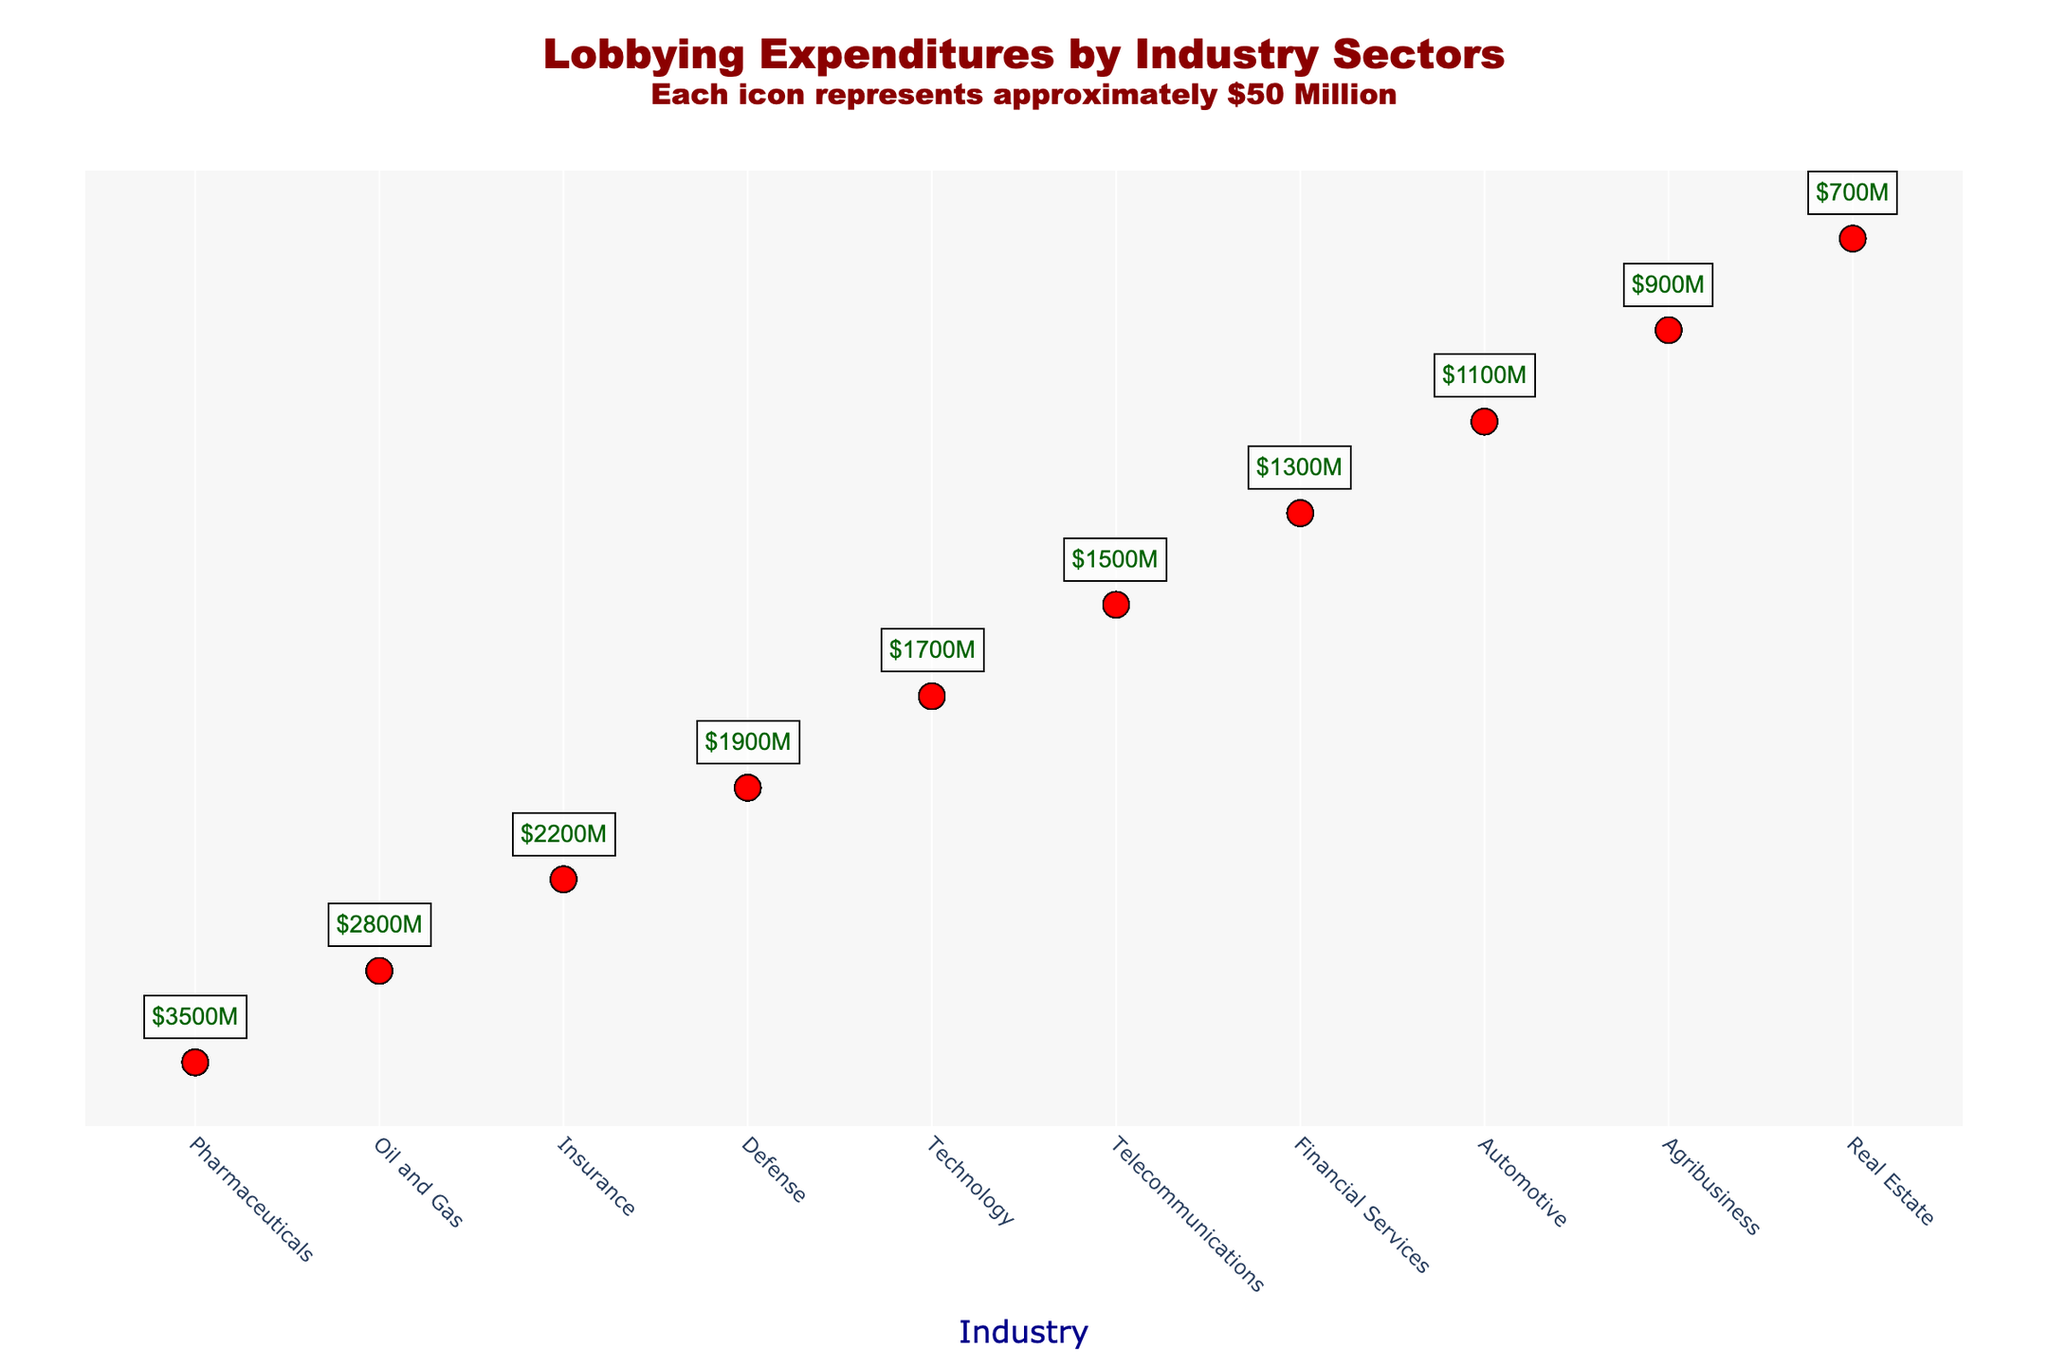What's the highest lobbying expenditure by an industry sector? By examining the plot, the Pharmaceutical industry shows the highest number of icons, which translate to the highest expenditure. Checking the exact amount, each icon represents $50 million, and Pharmaceuticals have 70 icons. 70 icons multiplied by $50 million equals $3500 million.
Answer: $3500 million Which two industries have the closest lobbying expenditures? By counting the icons for each industry, you can observe that the Technology sector, which has 34 icons, and Telecommunications sector, which has 30 icons, have the closest number of icons. Hence, their expenditures would be relatively close, with Technology at $1700 million and Telecommunications at $1500 million. The difference is $200 million.
Answer: Technology and Telecommunications What is the total lobbying expenditure of the top three industries? Identify the top three industries by their icon counts: Pharmaceuticals (70 icons), Oil and Gas (56 icons), and Insurance (44 icons). Calculating the total expenditure: (70 * $50 million) + (56 * $50 million) + (44 * $50 million) = $3500 million + $2800 million + $2200 million = $8500 million.
Answer: $8500 million Which industry has spent the least on lobbying? The plot shows the Real Estate industry at the bottom with only 14 icons. Therefore, Real Estate spent 14 * $50 million = $700 million.
Answer: Real Estate How much more did the Defense sector spend compared to Agribusiness? The Defense sector has 38 icons while Agribusiness has 18 icons. Calculating their expenditures: Defense spent 38 * $50 million = $1900 million; Agribusiness spent 18 * $50 million = $900 million. The difference is $1900 million - $900 million = $1000 million.
Answer: $1000 million What's the average expenditure across all industry sectors shown in the plot? Sum all industry expenditures: (70+56+44+38+34+30+26+22+18+14) * $50 million = 3520 total icons * $50 million = $17600 million total expenditure. Divide by the number of industries (10): $17600 million / 10 = $1760 million.
Answer: $1760 million Which sectors have more than $2000 million in lobbying expenditures? Count the icons and convert to expenditure: Pharmaceuticals (70 icons, $3500 million), Oil and Gas (56 icons, $2800 million), and Insurance (44 icons, $2200 million). These three sectors each have more than $2000 million in expenditures.
Answer: Pharmaceuticals, Oil and Gas, Insurance If the total lobbying expenditure increased by 10% across all sectors, what would be the new expenditure for the Financial Services industry? Financial Services currently has 26 icons, equating to $1300 million. An increase by 10% is (10/100) * $1300 million = $130 million. Adding this to the original: $1300 million + $130 million = $1430 million.
Answer: $1430 million How many sectors have expenditures between $1000 million and $2000 million? Identify the sectors within this range: Defense (38 icons, $1900 million), Technology (34 icons, $1700 million), Telecommunications (30 icons, $1500 million), Financial Services (26 icons, $1300 million), and Automotive (22 icons, $1100 million). There are 5 sectors within this range.
Answer: 5 